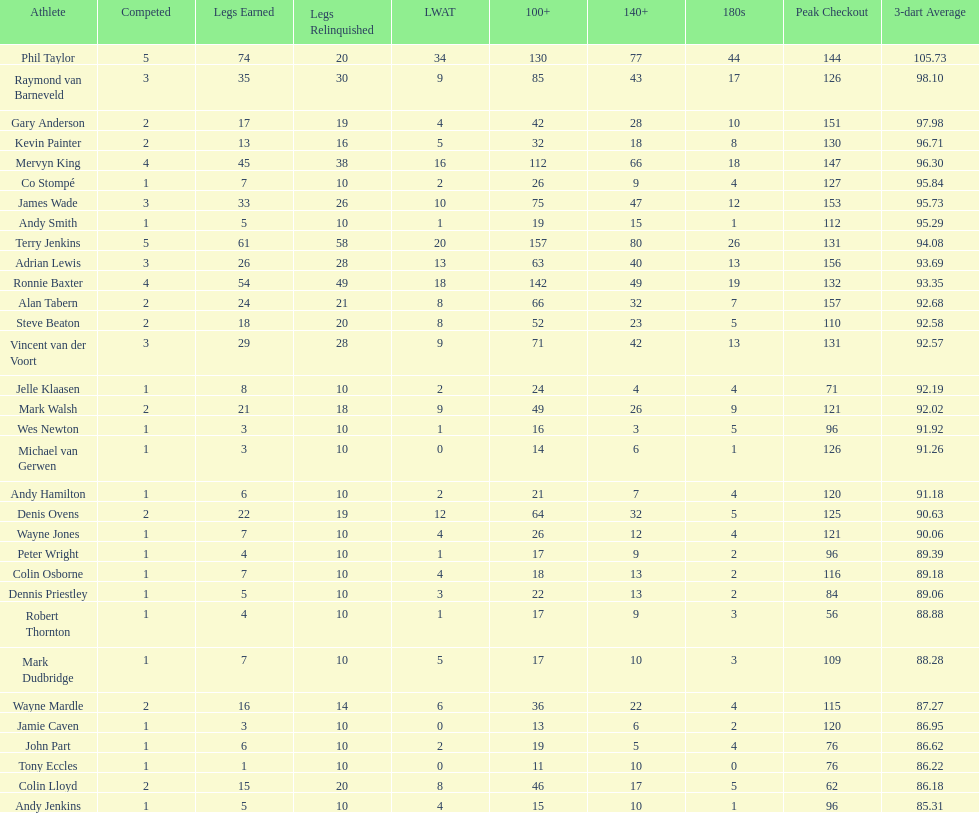Was andy smith or kevin painter's 3-dart average 96.71? Kevin Painter. 